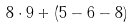<formula> <loc_0><loc_0><loc_500><loc_500>8 \cdot 9 + ( 5 - 6 - 8 )</formula> 